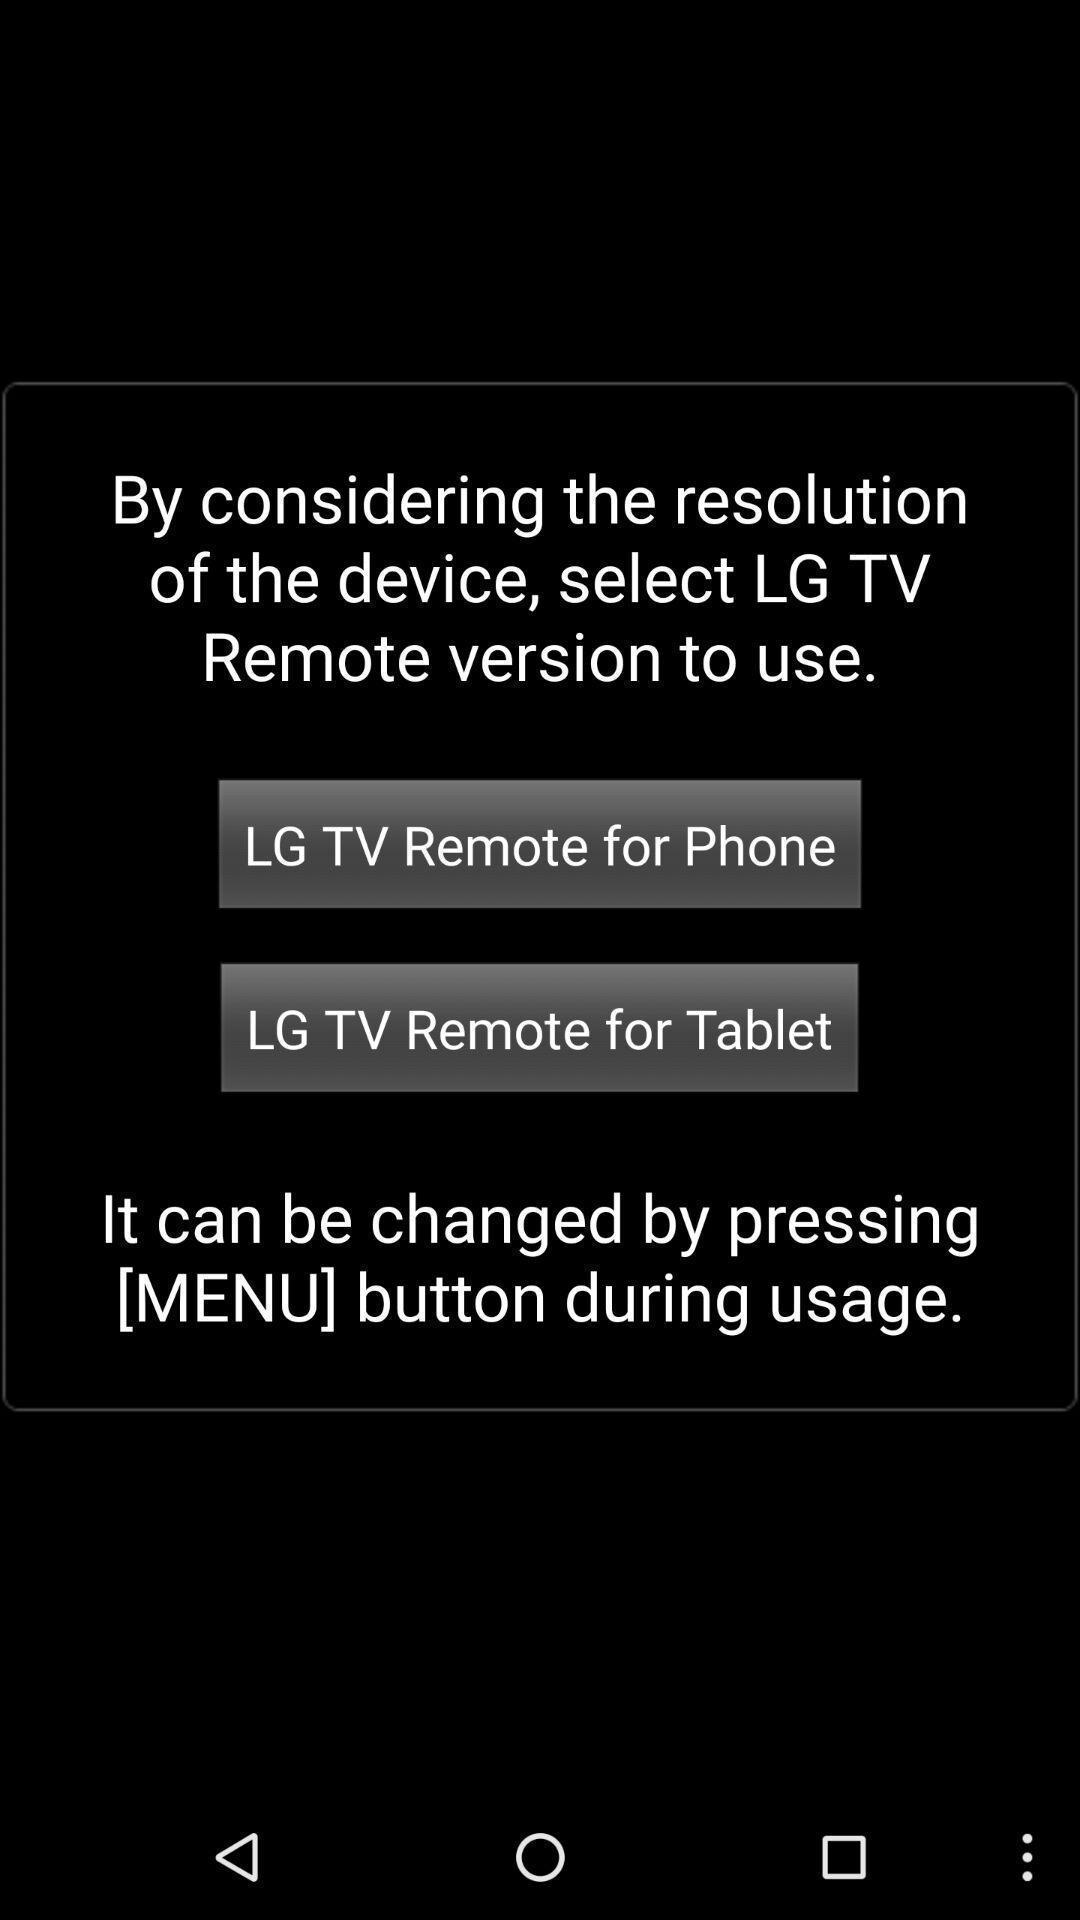Explain what's happening in this screen capture. Screen displaying information about a product. 